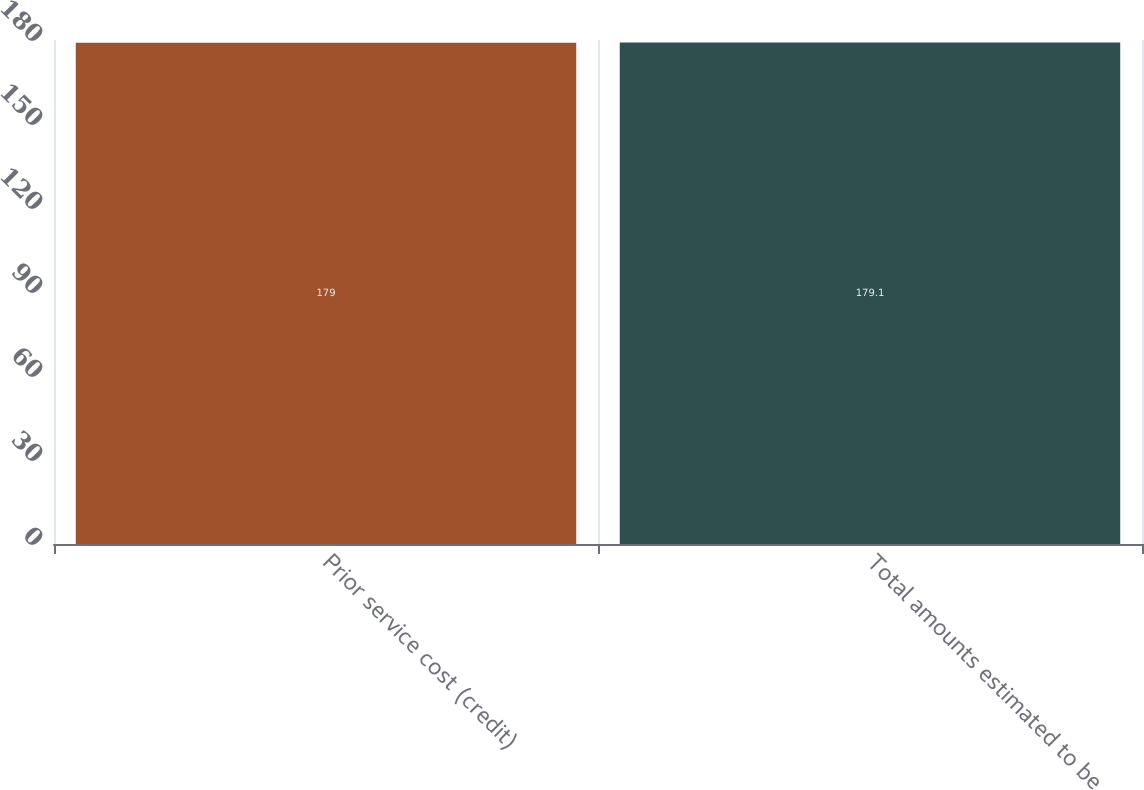Convert chart to OTSL. <chart><loc_0><loc_0><loc_500><loc_500><bar_chart><fcel>Prior service cost (credit)<fcel>Total amounts estimated to be<nl><fcel>179<fcel>179.1<nl></chart> 